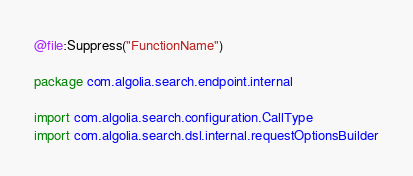Convert code to text. <code><loc_0><loc_0><loc_500><loc_500><_Kotlin_>@file:Suppress("FunctionName")

package com.algolia.search.endpoint.internal

import com.algolia.search.configuration.CallType
import com.algolia.search.dsl.internal.requestOptionsBuilder</code> 